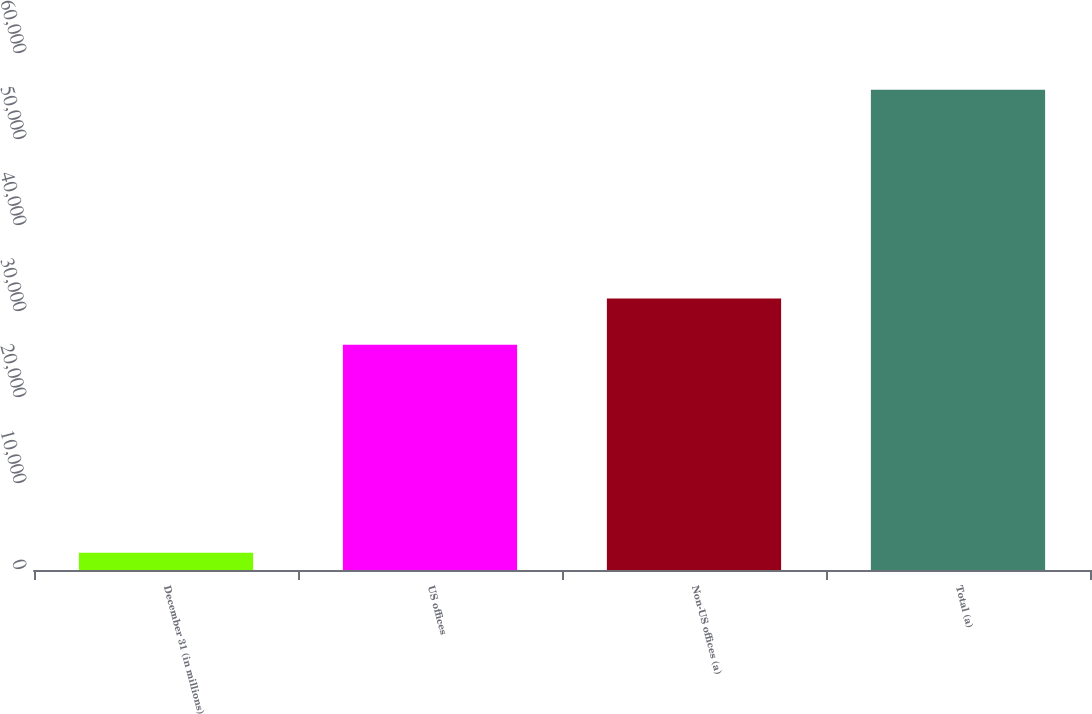Convert chart. <chart><loc_0><loc_0><loc_500><loc_500><bar_chart><fcel>December 31 (in millions)<fcel>US offices<fcel>Non-US offices (a)<fcel>Total (a)<nl><fcel>2016<fcel>26180<fcel>31561.6<fcel>55832<nl></chart> 